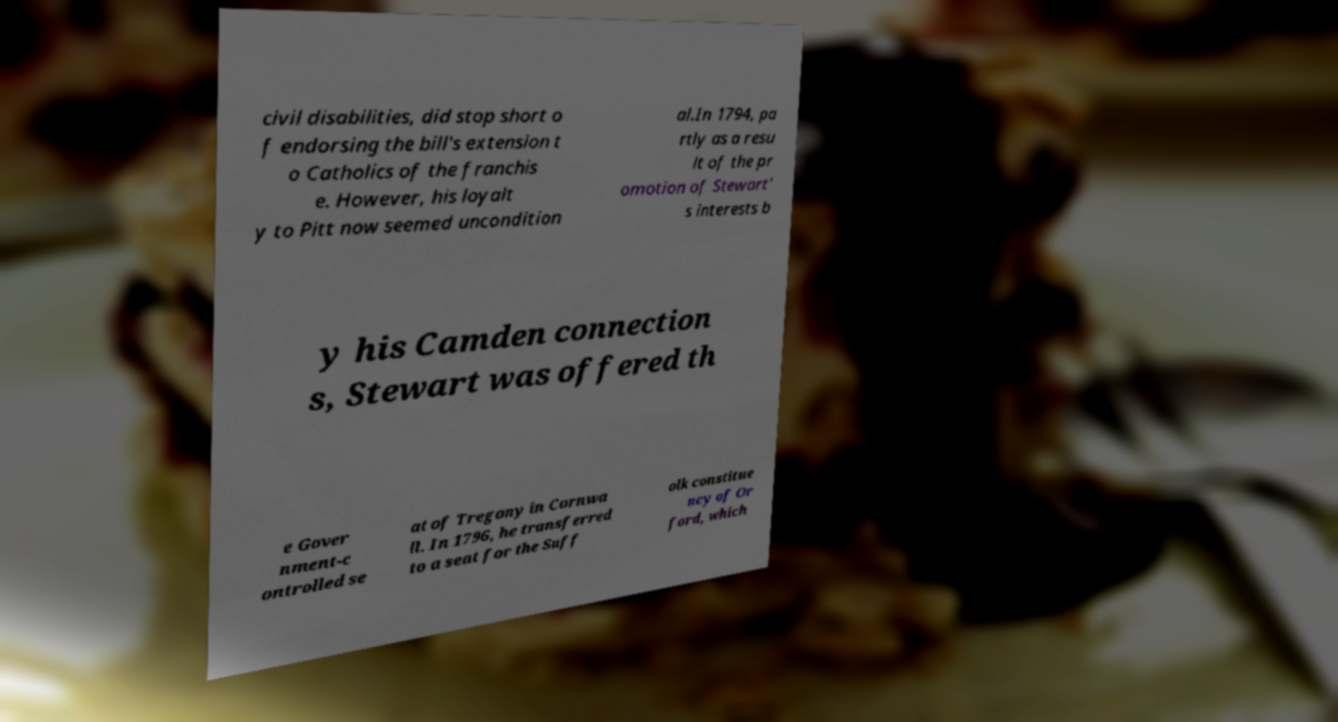I need the written content from this picture converted into text. Can you do that? civil disabilities, did stop short o f endorsing the bill's extension t o Catholics of the franchis e. However, his loyalt y to Pitt now seemed uncondition al.In 1794, pa rtly as a resu lt of the pr omotion of Stewart' s interests b y his Camden connection s, Stewart was offered th e Gover nment-c ontrolled se at of Tregony in Cornwa ll. In 1796, he transferred to a seat for the Suff olk constitue ncy of Or ford, which 